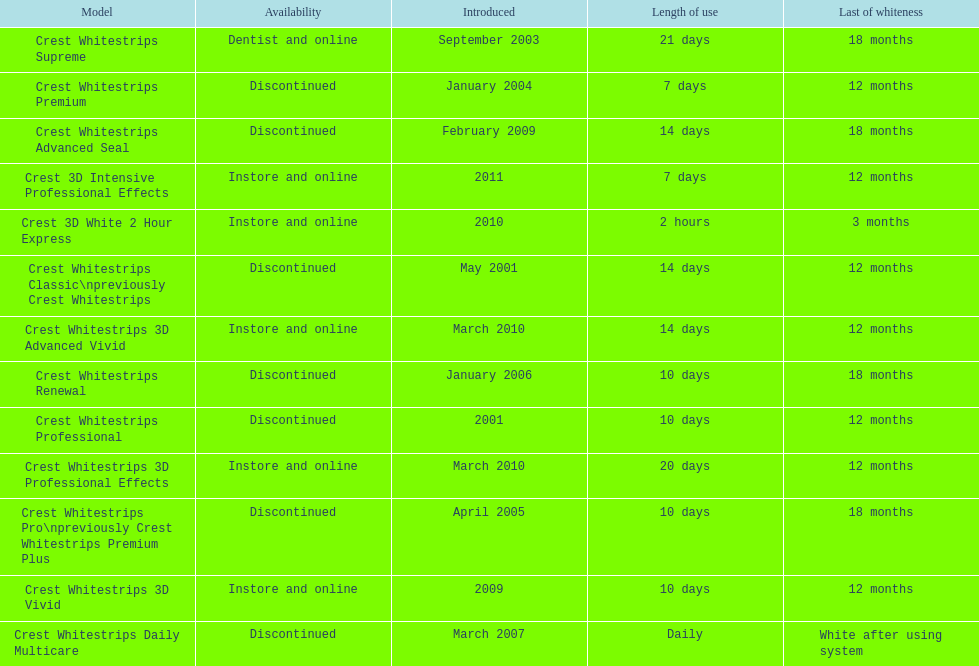Does the crest white strips pro last as long as the crest white strips renewal? Yes. 